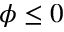<formula> <loc_0><loc_0><loc_500><loc_500>\phi \leq 0</formula> 